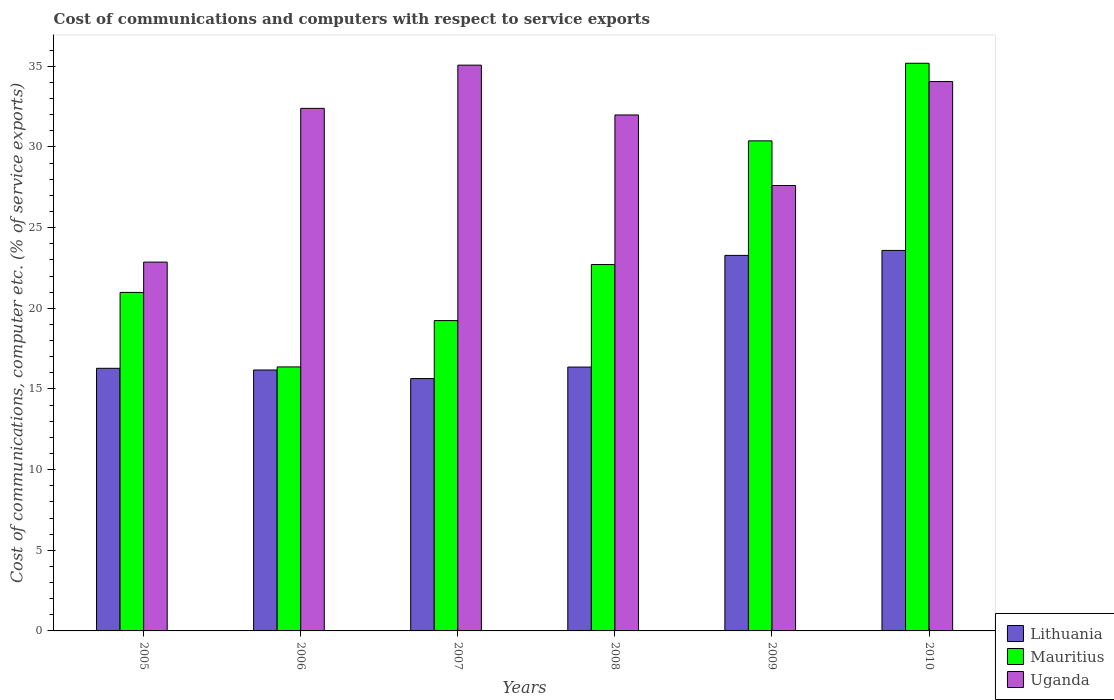How many different coloured bars are there?
Provide a short and direct response. 3. How many groups of bars are there?
Your response must be concise. 6. Are the number of bars on each tick of the X-axis equal?
Provide a short and direct response. Yes. How many bars are there on the 2nd tick from the left?
Keep it short and to the point. 3. What is the cost of communications and computers in Lithuania in 2006?
Keep it short and to the point. 16.18. Across all years, what is the maximum cost of communications and computers in Mauritius?
Provide a succinct answer. 35.19. Across all years, what is the minimum cost of communications and computers in Uganda?
Your response must be concise. 22.86. In which year was the cost of communications and computers in Lithuania maximum?
Your response must be concise. 2010. In which year was the cost of communications and computers in Uganda minimum?
Offer a very short reply. 2005. What is the total cost of communications and computers in Mauritius in the graph?
Ensure brevity in your answer.  144.87. What is the difference between the cost of communications and computers in Mauritius in 2007 and that in 2010?
Ensure brevity in your answer.  -15.95. What is the difference between the cost of communications and computers in Uganda in 2007 and the cost of communications and computers in Mauritius in 2010?
Provide a succinct answer. -0.12. What is the average cost of communications and computers in Lithuania per year?
Offer a very short reply. 18.55. In the year 2005, what is the difference between the cost of communications and computers in Lithuania and cost of communications and computers in Uganda?
Provide a succinct answer. -6.58. In how many years, is the cost of communications and computers in Uganda greater than 13 %?
Offer a very short reply. 6. What is the ratio of the cost of communications and computers in Lithuania in 2005 to that in 2008?
Your response must be concise. 1. What is the difference between the highest and the second highest cost of communications and computers in Mauritius?
Ensure brevity in your answer.  4.81. What is the difference between the highest and the lowest cost of communications and computers in Uganda?
Your response must be concise. 12.21. In how many years, is the cost of communications and computers in Lithuania greater than the average cost of communications and computers in Lithuania taken over all years?
Make the answer very short. 2. Is the sum of the cost of communications and computers in Uganda in 2005 and 2006 greater than the maximum cost of communications and computers in Lithuania across all years?
Make the answer very short. Yes. What does the 1st bar from the left in 2005 represents?
Provide a succinct answer. Lithuania. What does the 1st bar from the right in 2007 represents?
Keep it short and to the point. Uganda. Is it the case that in every year, the sum of the cost of communications and computers in Lithuania and cost of communications and computers in Uganda is greater than the cost of communications and computers in Mauritius?
Your answer should be very brief. Yes. Are all the bars in the graph horizontal?
Keep it short and to the point. No. How many legend labels are there?
Offer a very short reply. 3. What is the title of the graph?
Your answer should be compact. Cost of communications and computers with respect to service exports. Does "Russian Federation" appear as one of the legend labels in the graph?
Make the answer very short. No. What is the label or title of the Y-axis?
Your response must be concise. Cost of communications, computer etc. (% of service exports). What is the Cost of communications, computer etc. (% of service exports) of Lithuania in 2005?
Make the answer very short. 16.28. What is the Cost of communications, computer etc. (% of service exports) of Mauritius in 2005?
Give a very brief answer. 20.99. What is the Cost of communications, computer etc. (% of service exports) of Uganda in 2005?
Provide a short and direct response. 22.86. What is the Cost of communications, computer etc. (% of service exports) of Lithuania in 2006?
Your answer should be very brief. 16.18. What is the Cost of communications, computer etc. (% of service exports) in Mauritius in 2006?
Provide a succinct answer. 16.37. What is the Cost of communications, computer etc. (% of service exports) in Uganda in 2006?
Your answer should be compact. 32.39. What is the Cost of communications, computer etc. (% of service exports) in Lithuania in 2007?
Offer a terse response. 15.64. What is the Cost of communications, computer etc. (% of service exports) in Mauritius in 2007?
Your answer should be very brief. 19.24. What is the Cost of communications, computer etc. (% of service exports) of Uganda in 2007?
Provide a succinct answer. 35.07. What is the Cost of communications, computer etc. (% of service exports) of Lithuania in 2008?
Make the answer very short. 16.36. What is the Cost of communications, computer etc. (% of service exports) of Mauritius in 2008?
Provide a succinct answer. 22.71. What is the Cost of communications, computer etc. (% of service exports) in Uganda in 2008?
Keep it short and to the point. 31.99. What is the Cost of communications, computer etc. (% of service exports) in Lithuania in 2009?
Make the answer very short. 23.28. What is the Cost of communications, computer etc. (% of service exports) of Mauritius in 2009?
Make the answer very short. 30.38. What is the Cost of communications, computer etc. (% of service exports) of Uganda in 2009?
Offer a very short reply. 27.61. What is the Cost of communications, computer etc. (% of service exports) of Lithuania in 2010?
Give a very brief answer. 23.59. What is the Cost of communications, computer etc. (% of service exports) in Mauritius in 2010?
Give a very brief answer. 35.19. What is the Cost of communications, computer etc. (% of service exports) in Uganda in 2010?
Offer a terse response. 34.06. Across all years, what is the maximum Cost of communications, computer etc. (% of service exports) in Lithuania?
Provide a short and direct response. 23.59. Across all years, what is the maximum Cost of communications, computer etc. (% of service exports) in Mauritius?
Your response must be concise. 35.19. Across all years, what is the maximum Cost of communications, computer etc. (% of service exports) of Uganda?
Keep it short and to the point. 35.07. Across all years, what is the minimum Cost of communications, computer etc. (% of service exports) of Lithuania?
Make the answer very short. 15.64. Across all years, what is the minimum Cost of communications, computer etc. (% of service exports) of Mauritius?
Offer a terse response. 16.37. Across all years, what is the minimum Cost of communications, computer etc. (% of service exports) of Uganda?
Keep it short and to the point. 22.86. What is the total Cost of communications, computer etc. (% of service exports) of Lithuania in the graph?
Provide a short and direct response. 111.32. What is the total Cost of communications, computer etc. (% of service exports) of Mauritius in the graph?
Your answer should be very brief. 144.87. What is the total Cost of communications, computer etc. (% of service exports) of Uganda in the graph?
Make the answer very short. 183.99. What is the difference between the Cost of communications, computer etc. (% of service exports) in Lithuania in 2005 and that in 2006?
Keep it short and to the point. 0.1. What is the difference between the Cost of communications, computer etc. (% of service exports) in Mauritius in 2005 and that in 2006?
Offer a very short reply. 4.62. What is the difference between the Cost of communications, computer etc. (% of service exports) of Uganda in 2005 and that in 2006?
Your answer should be very brief. -9.53. What is the difference between the Cost of communications, computer etc. (% of service exports) of Lithuania in 2005 and that in 2007?
Make the answer very short. 0.64. What is the difference between the Cost of communications, computer etc. (% of service exports) of Mauritius in 2005 and that in 2007?
Offer a terse response. 1.75. What is the difference between the Cost of communications, computer etc. (% of service exports) in Uganda in 2005 and that in 2007?
Your answer should be compact. -12.21. What is the difference between the Cost of communications, computer etc. (% of service exports) of Lithuania in 2005 and that in 2008?
Provide a short and direct response. -0.08. What is the difference between the Cost of communications, computer etc. (% of service exports) in Mauritius in 2005 and that in 2008?
Offer a terse response. -1.73. What is the difference between the Cost of communications, computer etc. (% of service exports) of Uganda in 2005 and that in 2008?
Provide a succinct answer. -9.12. What is the difference between the Cost of communications, computer etc. (% of service exports) of Lithuania in 2005 and that in 2009?
Offer a terse response. -7. What is the difference between the Cost of communications, computer etc. (% of service exports) in Mauritius in 2005 and that in 2009?
Offer a very short reply. -9.4. What is the difference between the Cost of communications, computer etc. (% of service exports) in Uganda in 2005 and that in 2009?
Give a very brief answer. -4.75. What is the difference between the Cost of communications, computer etc. (% of service exports) in Lithuania in 2005 and that in 2010?
Your answer should be very brief. -7.31. What is the difference between the Cost of communications, computer etc. (% of service exports) in Mauritius in 2005 and that in 2010?
Offer a very short reply. -14.21. What is the difference between the Cost of communications, computer etc. (% of service exports) in Uganda in 2005 and that in 2010?
Give a very brief answer. -11.19. What is the difference between the Cost of communications, computer etc. (% of service exports) of Lithuania in 2006 and that in 2007?
Provide a short and direct response. 0.53. What is the difference between the Cost of communications, computer etc. (% of service exports) of Mauritius in 2006 and that in 2007?
Your answer should be compact. -2.87. What is the difference between the Cost of communications, computer etc. (% of service exports) in Uganda in 2006 and that in 2007?
Provide a short and direct response. -2.68. What is the difference between the Cost of communications, computer etc. (% of service exports) of Lithuania in 2006 and that in 2008?
Make the answer very short. -0.18. What is the difference between the Cost of communications, computer etc. (% of service exports) in Mauritius in 2006 and that in 2008?
Offer a terse response. -6.35. What is the difference between the Cost of communications, computer etc. (% of service exports) of Uganda in 2006 and that in 2008?
Provide a succinct answer. 0.41. What is the difference between the Cost of communications, computer etc. (% of service exports) of Lithuania in 2006 and that in 2009?
Ensure brevity in your answer.  -7.1. What is the difference between the Cost of communications, computer etc. (% of service exports) in Mauritius in 2006 and that in 2009?
Provide a succinct answer. -14.01. What is the difference between the Cost of communications, computer etc. (% of service exports) of Uganda in 2006 and that in 2009?
Your answer should be very brief. 4.78. What is the difference between the Cost of communications, computer etc. (% of service exports) of Lithuania in 2006 and that in 2010?
Make the answer very short. -7.41. What is the difference between the Cost of communications, computer etc. (% of service exports) of Mauritius in 2006 and that in 2010?
Provide a succinct answer. -18.82. What is the difference between the Cost of communications, computer etc. (% of service exports) in Uganda in 2006 and that in 2010?
Ensure brevity in your answer.  -1.66. What is the difference between the Cost of communications, computer etc. (% of service exports) in Lithuania in 2007 and that in 2008?
Offer a terse response. -0.71. What is the difference between the Cost of communications, computer etc. (% of service exports) in Mauritius in 2007 and that in 2008?
Your answer should be compact. -3.47. What is the difference between the Cost of communications, computer etc. (% of service exports) of Uganda in 2007 and that in 2008?
Offer a very short reply. 3.09. What is the difference between the Cost of communications, computer etc. (% of service exports) in Lithuania in 2007 and that in 2009?
Your response must be concise. -7.64. What is the difference between the Cost of communications, computer etc. (% of service exports) in Mauritius in 2007 and that in 2009?
Provide a short and direct response. -11.14. What is the difference between the Cost of communications, computer etc. (% of service exports) in Uganda in 2007 and that in 2009?
Offer a very short reply. 7.46. What is the difference between the Cost of communications, computer etc. (% of service exports) in Lithuania in 2007 and that in 2010?
Provide a succinct answer. -7.94. What is the difference between the Cost of communications, computer etc. (% of service exports) of Mauritius in 2007 and that in 2010?
Give a very brief answer. -15.95. What is the difference between the Cost of communications, computer etc. (% of service exports) of Uganda in 2007 and that in 2010?
Make the answer very short. 1.02. What is the difference between the Cost of communications, computer etc. (% of service exports) in Lithuania in 2008 and that in 2009?
Make the answer very short. -6.92. What is the difference between the Cost of communications, computer etc. (% of service exports) in Mauritius in 2008 and that in 2009?
Keep it short and to the point. -7.67. What is the difference between the Cost of communications, computer etc. (% of service exports) in Uganda in 2008 and that in 2009?
Your answer should be very brief. 4.37. What is the difference between the Cost of communications, computer etc. (% of service exports) of Lithuania in 2008 and that in 2010?
Give a very brief answer. -7.23. What is the difference between the Cost of communications, computer etc. (% of service exports) of Mauritius in 2008 and that in 2010?
Your response must be concise. -12.48. What is the difference between the Cost of communications, computer etc. (% of service exports) in Uganda in 2008 and that in 2010?
Your response must be concise. -2.07. What is the difference between the Cost of communications, computer etc. (% of service exports) in Lithuania in 2009 and that in 2010?
Make the answer very short. -0.31. What is the difference between the Cost of communications, computer etc. (% of service exports) of Mauritius in 2009 and that in 2010?
Give a very brief answer. -4.81. What is the difference between the Cost of communications, computer etc. (% of service exports) of Uganda in 2009 and that in 2010?
Ensure brevity in your answer.  -6.45. What is the difference between the Cost of communications, computer etc. (% of service exports) of Lithuania in 2005 and the Cost of communications, computer etc. (% of service exports) of Mauritius in 2006?
Your answer should be very brief. -0.09. What is the difference between the Cost of communications, computer etc. (% of service exports) in Lithuania in 2005 and the Cost of communications, computer etc. (% of service exports) in Uganda in 2006?
Ensure brevity in your answer.  -16.11. What is the difference between the Cost of communications, computer etc. (% of service exports) of Mauritius in 2005 and the Cost of communications, computer etc. (% of service exports) of Uganda in 2006?
Offer a terse response. -11.41. What is the difference between the Cost of communications, computer etc. (% of service exports) of Lithuania in 2005 and the Cost of communications, computer etc. (% of service exports) of Mauritius in 2007?
Provide a short and direct response. -2.96. What is the difference between the Cost of communications, computer etc. (% of service exports) in Lithuania in 2005 and the Cost of communications, computer etc. (% of service exports) in Uganda in 2007?
Ensure brevity in your answer.  -18.79. What is the difference between the Cost of communications, computer etc. (% of service exports) in Mauritius in 2005 and the Cost of communications, computer etc. (% of service exports) in Uganda in 2007?
Offer a very short reply. -14.09. What is the difference between the Cost of communications, computer etc. (% of service exports) of Lithuania in 2005 and the Cost of communications, computer etc. (% of service exports) of Mauritius in 2008?
Offer a terse response. -6.43. What is the difference between the Cost of communications, computer etc. (% of service exports) of Lithuania in 2005 and the Cost of communications, computer etc. (% of service exports) of Uganda in 2008?
Keep it short and to the point. -15.71. What is the difference between the Cost of communications, computer etc. (% of service exports) of Mauritius in 2005 and the Cost of communications, computer etc. (% of service exports) of Uganda in 2008?
Give a very brief answer. -11. What is the difference between the Cost of communications, computer etc. (% of service exports) in Lithuania in 2005 and the Cost of communications, computer etc. (% of service exports) in Mauritius in 2009?
Keep it short and to the point. -14.1. What is the difference between the Cost of communications, computer etc. (% of service exports) of Lithuania in 2005 and the Cost of communications, computer etc. (% of service exports) of Uganda in 2009?
Make the answer very short. -11.33. What is the difference between the Cost of communications, computer etc. (% of service exports) in Mauritius in 2005 and the Cost of communications, computer etc. (% of service exports) in Uganda in 2009?
Ensure brevity in your answer.  -6.63. What is the difference between the Cost of communications, computer etc. (% of service exports) in Lithuania in 2005 and the Cost of communications, computer etc. (% of service exports) in Mauritius in 2010?
Your response must be concise. -18.91. What is the difference between the Cost of communications, computer etc. (% of service exports) in Lithuania in 2005 and the Cost of communications, computer etc. (% of service exports) in Uganda in 2010?
Give a very brief answer. -17.78. What is the difference between the Cost of communications, computer etc. (% of service exports) of Mauritius in 2005 and the Cost of communications, computer etc. (% of service exports) of Uganda in 2010?
Provide a short and direct response. -13.07. What is the difference between the Cost of communications, computer etc. (% of service exports) of Lithuania in 2006 and the Cost of communications, computer etc. (% of service exports) of Mauritius in 2007?
Your answer should be very brief. -3.06. What is the difference between the Cost of communications, computer etc. (% of service exports) in Lithuania in 2006 and the Cost of communications, computer etc. (% of service exports) in Uganda in 2007?
Keep it short and to the point. -18.9. What is the difference between the Cost of communications, computer etc. (% of service exports) in Mauritius in 2006 and the Cost of communications, computer etc. (% of service exports) in Uganda in 2007?
Keep it short and to the point. -18.71. What is the difference between the Cost of communications, computer etc. (% of service exports) of Lithuania in 2006 and the Cost of communications, computer etc. (% of service exports) of Mauritius in 2008?
Provide a short and direct response. -6.54. What is the difference between the Cost of communications, computer etc. (% of service exports) of Lithuania in 2006 and the Cost of communications, computer etc. (% of service exports) of Uganda in 2008?
Give a very brief answer. -15.81. What is the difference between the Cost of communications, computer etc. (% of service exports) in Mauritius in 2006 and the Cost of communications, computer etc. (% of service exports) in Uganda in 2008?
Your answer should be very brief. -15.62. What is the difference between the Cost of communications, computer etc. (% of service exports) in Lithuania in 2006 and the Cost of communications, computer etc. (% of service exports) in Mauritius in 2009?
Your answer should be compact. -14.2. What is the difference between the Cost of communications, computer etc. (% of service exports) of Lithuania in 2006 and the Cost of communications, computer etc. (% of service exports) of Uganda in 2009?
Provide a succinct answer. -11.44. What is the difference between the Cost of communications, computer etc. (% of service exports) of Mauritius in 2006 and the Cost of communications, computer etc. (% of service exports) of Uganda in 2009?
Keep it short and to the point. -11.25. What is the difference between the Cost of communications, computer etc. (% of service exports) in Lithuania in 2006 and the Cost of communications, computer etc. (% of service exports) in Mauritius in 2010?
Give a very brief answer. -19.01. What is the difference between the Cost of communications, computer etc. (% of service exports) of Lithuania in 2006 and the Cost of communications, computer etc. (% of service exports) of Uganda in 2010?
Ensure brevity in your answer.  -17.88. What is the difference between the Cost of communications, computer etc. (% of service exports) in Mauritius in 2006 and the Cost of communications, computer etc. (% of service exports) in Uganda in 2010?
Keep it short and to the point. -17.69. What is the difference between the Cost of communications, computer etc. (% of service exports) in Lithuania in 2007 and the Cost of communications, computer etc. (% of service exports) in Mauritius in 2008?
Your answer should be compact. -7.07. What is the difference between the Cost of communications, computer etc. (% of service exports) of Lithuania in 2007 and the Cost of communications, computer etc. (% of service exports) of Uganda in 2008?
Your answer should be very brief. -16.34. What is the difference between the Cost of communications, computer etc. (% of service exports) of Mauritius in 2007 and the Cost of communications, computer etc. (% of service exports) of Uganda in 2008?
Ensure brevity in your answer.  -12.75. What is the difference between the Cost of communications, computer etc. (% of service exports) of Lithuania in 2007 and the Cost of communications, computer etc. (% of service exports) of Mauritius in 2009?
Provide a succinct answer. -14.74. What is the difference between the Cost of communications, computer etc. (% of service exports) of Lithuania in 2007 and the Cost of communications, computer etc. (% of service exports) of Uganda in 2009?
Offer a terse response. -11.97. What is the difference between the Cost of communications, computer etc. (% of service exports) of Mauritius in 2007 and the Cost of communications, computer etc. (% of service exports) of Uganda in 2009?
Offer a very short reply. -8.37. What is the difference between the Cost of communications, computer etc. (% of service exports) in Lithuania in 2007 and the Cost of communications, computer etc. (% of service exports) in Mauritius in 2010?
Your response must be concise. -19.55. What is the difference between the Cost of communications, computer etc. (% of service exports) of Lithuania in 2007 and the Cost of communications, computer etc. (% of service exports) of Uganda in 2010?
Your response must be concise. -18.41. What is the difference between the Cost of communications, computer etc. (% of service exports) of Mauritius in 2007 and the Cost of communications, computer etc. (% of service exports) of Uganda in 2010?
Keep it short and to the point. -14.82. What is the difference between the Cost of communications, computer etc. (% of service exports) of Lithuania in 2008 and the Cost of communications, computer etc. (% of service exports) of Mauritius in 2009?
Give a very brief answer. -14.02. What is the difference between the Cost of communications, computer etc. (% of service exports) in Lithuania in 2008 and the Cost of communications, computer etc. (% of service exports) in Uganda in 2009?
Provide a short and direct response. -11.26. What is the difference between the Cost of communications, computer etc. (% of service exports) in Mauritius in 2008 and the Cost of communications, computer etc. (% of service exports) in Uganda in 2009?
Provide a short and direct response. -4.9. What is the difference between the Cost of communications, computer etc. (% of service exports) of Lithuania in 2008 and the Cost of communications, computer etc. (% of service exports) of Mauritius in 2010?
Your answer should be compact. -18.83. What is the difference between the Cost of communications, computer etc. (% of service exports) of Lithuania in 2008 and the Cost of communications, computer etc. (% of service exports) of Uganda in 2010?
Provide a succinct answer. -17.7. What is the difference between the Cost of communications, computer etc. (% of service exports) in Mauritius in 2008 and the Cost of communications, computer etc. (% of service exports) in Uganda in 2010?
Give a very brief answer. -11.35. What is the difference between the Cost of communications, computer etc. (% of service exports) of Lithuania in 2009 and the Cost of communications, computer etc. (% of service exports) of Mauritius in 2010?
Your answer should be very brief. -11.91. What is the difference between the Cost of communications, computer etc. (% of service exports) in Lithuania in 2009 and the Cost of communications, computer etc. (% of service exports) in Uganda in 2010?
Offer a terse response. -10.78. What is the difference between the Cost of communications, computer etc. (% of service exports) in Mauritius in 2009 and the Cost of communications, computer etc. (% of service exports) in Uganda in 2010?
Offer a terse response. -3.68. What is the average Cost of communications, computer etc. (% of service exports) in Lithuania per year?
Offer a terse response. 18.55. What is the average Cost of communications, computer etc. (% of service exports) of Mauritius per year?
Offer a terse response. 24.15. What is the average Cost of communications, computer etc. (% of service exports) of Uganda per year?
Your answer should be compact. 30.66. In the year 2005, what is the difference between the Cost of communications, computer etc. (% of service exports) in Lithuania and Cost of communications, computer etc. (% of service exports) in Mauritius?
Ensure brevity in your answer.  -4.71. In the year 2005, what is the difference between the Cost of communications, computer etc. (% of service exports) in Lithuania and Cost of communications, computer etc. (% of service exports) in Uganda?
Give a very brief answer. -6.58. In the year 2005, what is the difference between the Cost of communications, computer etc. (% of service exports) in Mauritius and Cost of communications, computer etc. (% of service exports) in Uganda?
Your response must be concise. -1.88. In the year 2006, what is the difference between the Cost of communications, computer etc. (% of service exports) of Lithuania and Cost of communications, computer etc. (% of service exports) of Mauritius?
Ensure brevity in your answer.  -0.19. In the year 2006, what is the difference between the Cost of communications, computer etc. (% of service exports) in Lithuania and Cost of communications, computer etc. (% of service exports) in Uganda?
Make the answer very short. -16.22. In the year 2006, what is the difference between the Cost of communications, computer etc. (% of service exports) of Mauritius and Cost of communications, computer etc. (% of service exports) of Uganda?
Your answer should be compact. -16.03. In the year 2007, what is the difference between the Cost of communications, computer etc. (% of service exports) of Lithuania and Cost of communications, computer etc. (% of service exports) of Mauritius?
Ensure brevity in your answer.  -3.59. In the year 2007, what is the difference between the Cost of communications, computer etc. (% of service exports) in Lithuania and Cost of communications, computer etc. (% of service exports) in Uganda?
Give a very brief answer. -19.43. In the year 2007, what is the difference between the Cost of communications, computer etc. (% of service exports) in Mauritius and Cost of communications, computer etc. (% of service exports) in Uganda?
Provide a short and direct response. -15.84. In the year 2008, what is the difference between the Cost of communications, computer etc. (% of service exports) in Lithuania and Cost of communications, computer etc. (% of service exports) in Mauritius?
Your answer should be compact. -6.36. In the year 2008, what is the difference between the Cost of communications, computer etc. (% of service exports) in Lithuania and Cost of communications, computer etc. (% of service exports) in Uganda?
Your answer should be compact. -15.63. In the year 2008, what is the difference between the Cost of communications, computer etc. (% of service exports) of Mauritius and Cost of communications, computer etc. (% of service exports) of Uganda?
Provide a short and direct response. -9.27. In the year 2009, what is the difference between the Cost of communications, computer etc. (% of service exports) of Lithuania and Cost of communications, computer etc. (% of service exports) of Mauritius?
Ensure brevity in your answer.  -7.1. In the year 2009, what is the difference between the Cost of communications, computer etc. (% of service exports) of Lithuania and Cost of communications, computer etc. (% of service exports) of Uganda?
Provide a succinct answer. -4.33. In the year 2009, what is the difference between the Cost of communications, computer etc. (% of service exports) of Mauritius and Cost of communications, computer etc. (% of service exports) of Uganda?
Your response must be concise. 2.77. In the year 2010, what is the difference between the Cost of communications, computer etc. (% of service exports) in Lithuania and Cost of communications, computer etc. (% of service exports) in Mauritius?
Offer a terse response. -11.6. In the year 2010, what is the difference between the Cost of communications, computer etc. (% of service exports) in Lithuania and Cost of communications, computer etc. (% of service exports) in Uganda?
Give a very brief answer. -10.47. In the year 2010, what is the difference between the Cost of communications, computer etc. (% of service exports) in Mauritius and Cost of communications, computer etc. (% of service exports) in Uganda?
Make the answer very short. 1.13. What is the ratio of the Cost of communications, computer etc. (% of service exports) of Lithuania in 2005 to that in 2006?
Give a very brief answer. 1.01. What is the ratio of the Cost of communications, computer etc. (% of service exports) of Mauritius in 2005 to that in 2006?
Offer a terse response. 1.28. What is the ratio of the Cost of communications, computer etc. (% of service exports) of Uganda in 2005 to that in 2006?
Your answer should be very brief. 0.71. What is the ratio of the Cost of communications, computer etc. (% of service exports) in Lithuania in 2005 to that in 2007?
Your answer should be compact. 1.04. What is the ratio of the Cost of communications, computer etc. (% of service exports) in Mauritius in 2005 to that in 2007?
Provide a succinct answer. 1.09. What is the ratio of the Cost of communications, computer etc. (% of service exports) of Uganda in 2005 to that in 2007?
Your answer should be very brief. 0.65. What is the ratio of the Cost of communications, computer etc. (% of service exports) in Lithuania in 2005 to that in 2008?
Offer a very short reply. 1. What is the ratio of the Cost of communications, computer etc. (% of service exports) in Mauritius in 2005 to that in 2008?
Make the answer very short. 0.92. What is the ratio of the Cost of communications, computer etc. (% of service exports) in Uganda in 2005 to that in 2008?
Keep it short and to the point. 0.71. What is the ratio of the Cost of communications, computer etc. (% of service exports) of Lithuania in 2005 to that in 2009?
Make the answer very short. 0.7. What is the ratio of the Cost of communications, computer etc. (% of service exports) in Mauritius in 2005 to that in 2009?
Give a very brief answer. 0.69. What is the ratio of the Cost of communications, computer etc. (% of service exports) in Uganda in 2005 to that in 2009?
Your answer should be compact. 0.83. What is the ratio of the Cost of communications, computer etc. (% of service exports) of Lithuania in 2005 to that in 2010?
Make the answer very short. 0.69. What is the ratio of the Cost of communications, computer etc. (% of service exports) in Mauritius in 2005 to that in 2010?
Your response must be concise. 0.6. What is the ratio of the Cost of communications, computer etc. (% of service exports) of Uganda in 2005 to that in 2010?
Ensure brevity in your answer.  0.67. What is the ratio of the Cost of communications, computer etc. (% of service exports) of Lithuania in 2006 to that in 2007?
Your answer should be compact. 1.03. What is the ratio of the Cost of communications, computer etc. (% of service exports) in Mauritius in 2006 to that in 2007?
Offer a terse response. 0.85. What is the ratio of the Cost of communications, computer etc. (% of service exports) of Uganda in 2006 to that in 2007?
Your response must be concise. 0.92. What is the ratio of the Cost of communications, computer etc. (% of service exports) of Lithuania in 2006 to that in 2008?
Your answer should be very brief. 0.99. What is the ratio of the Cost of communications, computer etc. (% of service exports) in Mauritius in 2006 to that in 2008?
Give a very brief answer. 0.72. What is the ratio of the Cost of communications, computer etc. (% of service exports) in Uganda in 2006 to that in 2008?
Provide a succinct answer. 1.01. What is the ratio of the Cost of communications, computer etc. (% of service exports) in Lithuania in 2006 to that in 2009?
Ensure brevity in your answer.  0.69. What is the ratio of the Cost of communications, computer etc. (% of service exports) of Mauritius in 2006 to that in 2009?
Give a very brief answer. 0.54. What is the ratio of the Cost of communications, computer etc. (% of service exports) of Uganda in 2006 to that in 2009?
Your response must be concise. 1.17. What is the ratio of the Cost of communications, computer etc. (% of service exports) of Lithuania in 2006 to that in 2010?
Give a very brief answer. 0.69. What is the ratio of the Cost of communications, computer etc. (% of service exports) in Mauritius in 2006 to that in 2010?
Offer a terse response. 0.47. What is the ratio of the Cost of communications, computer etc. (% of service exports) of Uganda in 2006 to that in 2010?
Provide a succinct answer. 0.95. What is the ratio of the Cost of communications, computer etc. (% of service exports) in Lithuania in 2007 to that in 2008?
Keep it short and to the point. 0.96. What is the ratio of the Cost of communications, computer etc. (% of service exports) in Mauritius in 2007 to that in 2008?
Your response must be concise. 0.85. What is the ratio of the Cost of communications, computer etc. (% of service exports) in Uganda in 2007 to that in 2008?
Provide a short and direct response. 1.1. What is the ratio of the Cost of communications, computer etc. (% of service exports) in Lithuania in 2007 to that in 2009?
Your answer should be compact. 0.67. What is the ratio of the Cost of communications, computer etc. (% of service exports) in Mauritius in 2007 to that in 2009?
Provide a short and direct response. 0.63. What is the ratio of the Cost of communications, computer etc. (% of service exports) in Uganda in 2007 to that in 2009?
Provide a succinct answer. 1.27. What is the ratio of the Cost of communications, computer etc. (% of service exports) in Lithuania in 2007 to that in 2010?
Offer a terse response. 0.66. What is the ratio of the Cost of communications, computer etc. (% of service exports) of Mauritius in 2007 to that in 2010?
Give a very brief answer. 0.55. What is the ratio of the Cost of communications, computer etc. (% of service exports) of Uganda in 2007 to that in 2010?
Keep it short and to the point. 1.03. What is the ratio of the Cost of communications, computer etc. (% of service exports) in Lithuania in 2008 to that in 2009?
Keep it short and to the point. 0.7. What is the ratio of the Cost of communications, computer etc. (% of service exports) in Mauritius in 2008 to that in 2009?
Provide a short and direct response. 0.75. What is the ratio of the Cost of communications, computer etc. (% of service exports) of Uganda in 2008 to that in 2009?
Your answer should be compact. 1.16. What is the ratio of the Cost of communications, computer etc. (% of service exports) of Lithuania in 2008 to that in 2010?
Your response must be concise. 0.69. What is the ratio of the Cost of communications, computer etc. (% of service exports) of Mauritius in 2008 to that in 2010?
Ensure brevity in your answer.  0.65. What is the ratio of the Cost of communications, computer etc. (% of service exports) of Uganda in 2008 to that in 2010?
Provide a short and direct response. 0.94. What is the ratio of the Cost of communications, computer etc. (% of service exports) of Lithuania in 2009 to that in 2010?
Offer a very short reply. 0.99. What is the ratio of the Cost of communications, computer etc. (% of service exports) in Mauritius in 2009 to that in 2010?
Give a very brief answer. 0.86. What is the ratio of the Cost of communications, computer etc. (% of service exports) in Uganda in 2009 to that in 2010?
Give a very brief answer. 0.81. What is the difference between the highest and the second highest Cost of communications, computer etc. (% of service exports) of Lithuania?
Give a very brief answer. 0.31. What is the difference between the highest and the second highest Cost of communications, computer etc. (% of service exports) in Mauritius?
Offer a terse response. 4.81. What is the difference between the highest and the second highest Cost of communications, computer etc. (% of service exports) of Uganda?
Provide a succinct answer. 1.02. What is the difference between the highest and the lowest Cost of communications, computer etc. (% of service exports) in Lithuania?
Your answer should be compact. 7.94. What is the difference between the highest and the lowest Cost of communications, computer etc. (% of service exports) of Mauritius?
Offer a very short reply. 18.82. What is the difference between the highest and the lowest Cost of communications, computer etc. (% of service exports) in Uganda?
Provide a succinct answer. 12.21. 